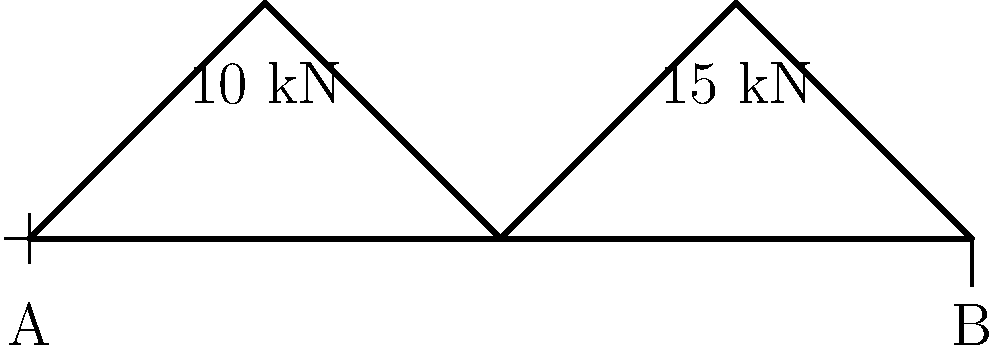Consider the simple truss bridge design shown above. The truss is subjected to two vertical loads: 10 kN at the first peak and 15 kN at the second peak. If the maximum allowable stress in any member is 200 MPa and each member has a cross-sectional area of 500 mm², what is the safety factor of the most stressed member? To solve this problem, we'll follow these steps:

1. Calculate the reaction forces at the supports:
   Let $R_A$ and $R_B$ be the reaction forces at supports A and B, respectively.
   $$\sum F_y = 0: R_A + R_B - 10 \text{ kN} - 15 \text{ kN} = 0$$
   $$\sum M_A = 0: 200R_B - 100(10) - 200(15) = 0$$
   
   Solving these equations:
   $R_B = 17.5 \text{ kN}$
   $R_A = 7.5 \text{ kN}$

2. Analyze the forces in the truss members:
   The most stressed member will likely be in the right triangle, where the 15 kN force is applied.
   Using the method of joints, we can find that the force in the diagonal member of this triangle is:
   $$F = \frac{15 \text{ kN}}{\sin 45°} = 21.21 \text{ kN}$$

3. Calculate the stress in this member:
   $$\sigma = \frac{F}{A} = \frac{21.21 \times 10^3 \text{ N}}{500 \text{ mm}^2} = 42.42 \text{ MPa}$$

4. Calculate the safety factor:
   Safety Factor $= \frac{\text{Allowable Stress}}{\text{Actual Stress}}$
   $$\text{Safety Factor} = \frac{200 \text{ MPa}}{42.42 \text{ MPa}} = 4.71$$

Therefore, the safety factor of the most stressed member is approximately 4.71.
Answer: 4.71 